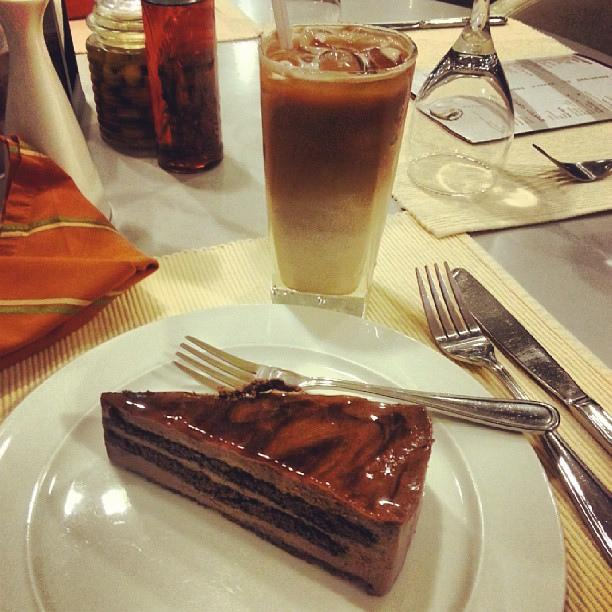What are they expecting to be poured into the upside down glass? Please explain your reasoning. wine. The upside down glass is a wine glass. 